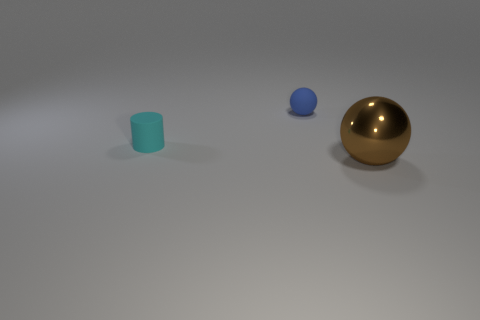Are there any other things that have the same material as the large brown ball?
Offer a very short reply. No. Are there fewer big blue metal balls than tiny cyan matte things?
Provide a succinct answer. Yes. There is a small thing behind the matte object that is in front of the sphere behind the small cyan matte thing; what is its material?
Ensure brevity in your answer.  Rubber. What material is the large brown ball?
Ensure brevity in your answer.  Metal. Are there more matte spheres than shiny cubes?
Your answer should be compact. Yes. There is another object that is the same shape as the brown object; what is its color?
Provide a short and direct response. Blue. The object that is both on the left side of the metallic object and on the right side of the small cyan matte object is made of what material?
Make the answer very short. Rubber. Does the sphere that is behind the big ball have the same material as the thing that is right of the blue object?
Provide a succinct answer. No. How big is the blue matte object?
Offer a very short reply. Small. What is the size of the other blue object that is the same shape as the big object?
Offer a very short reply. Small. 